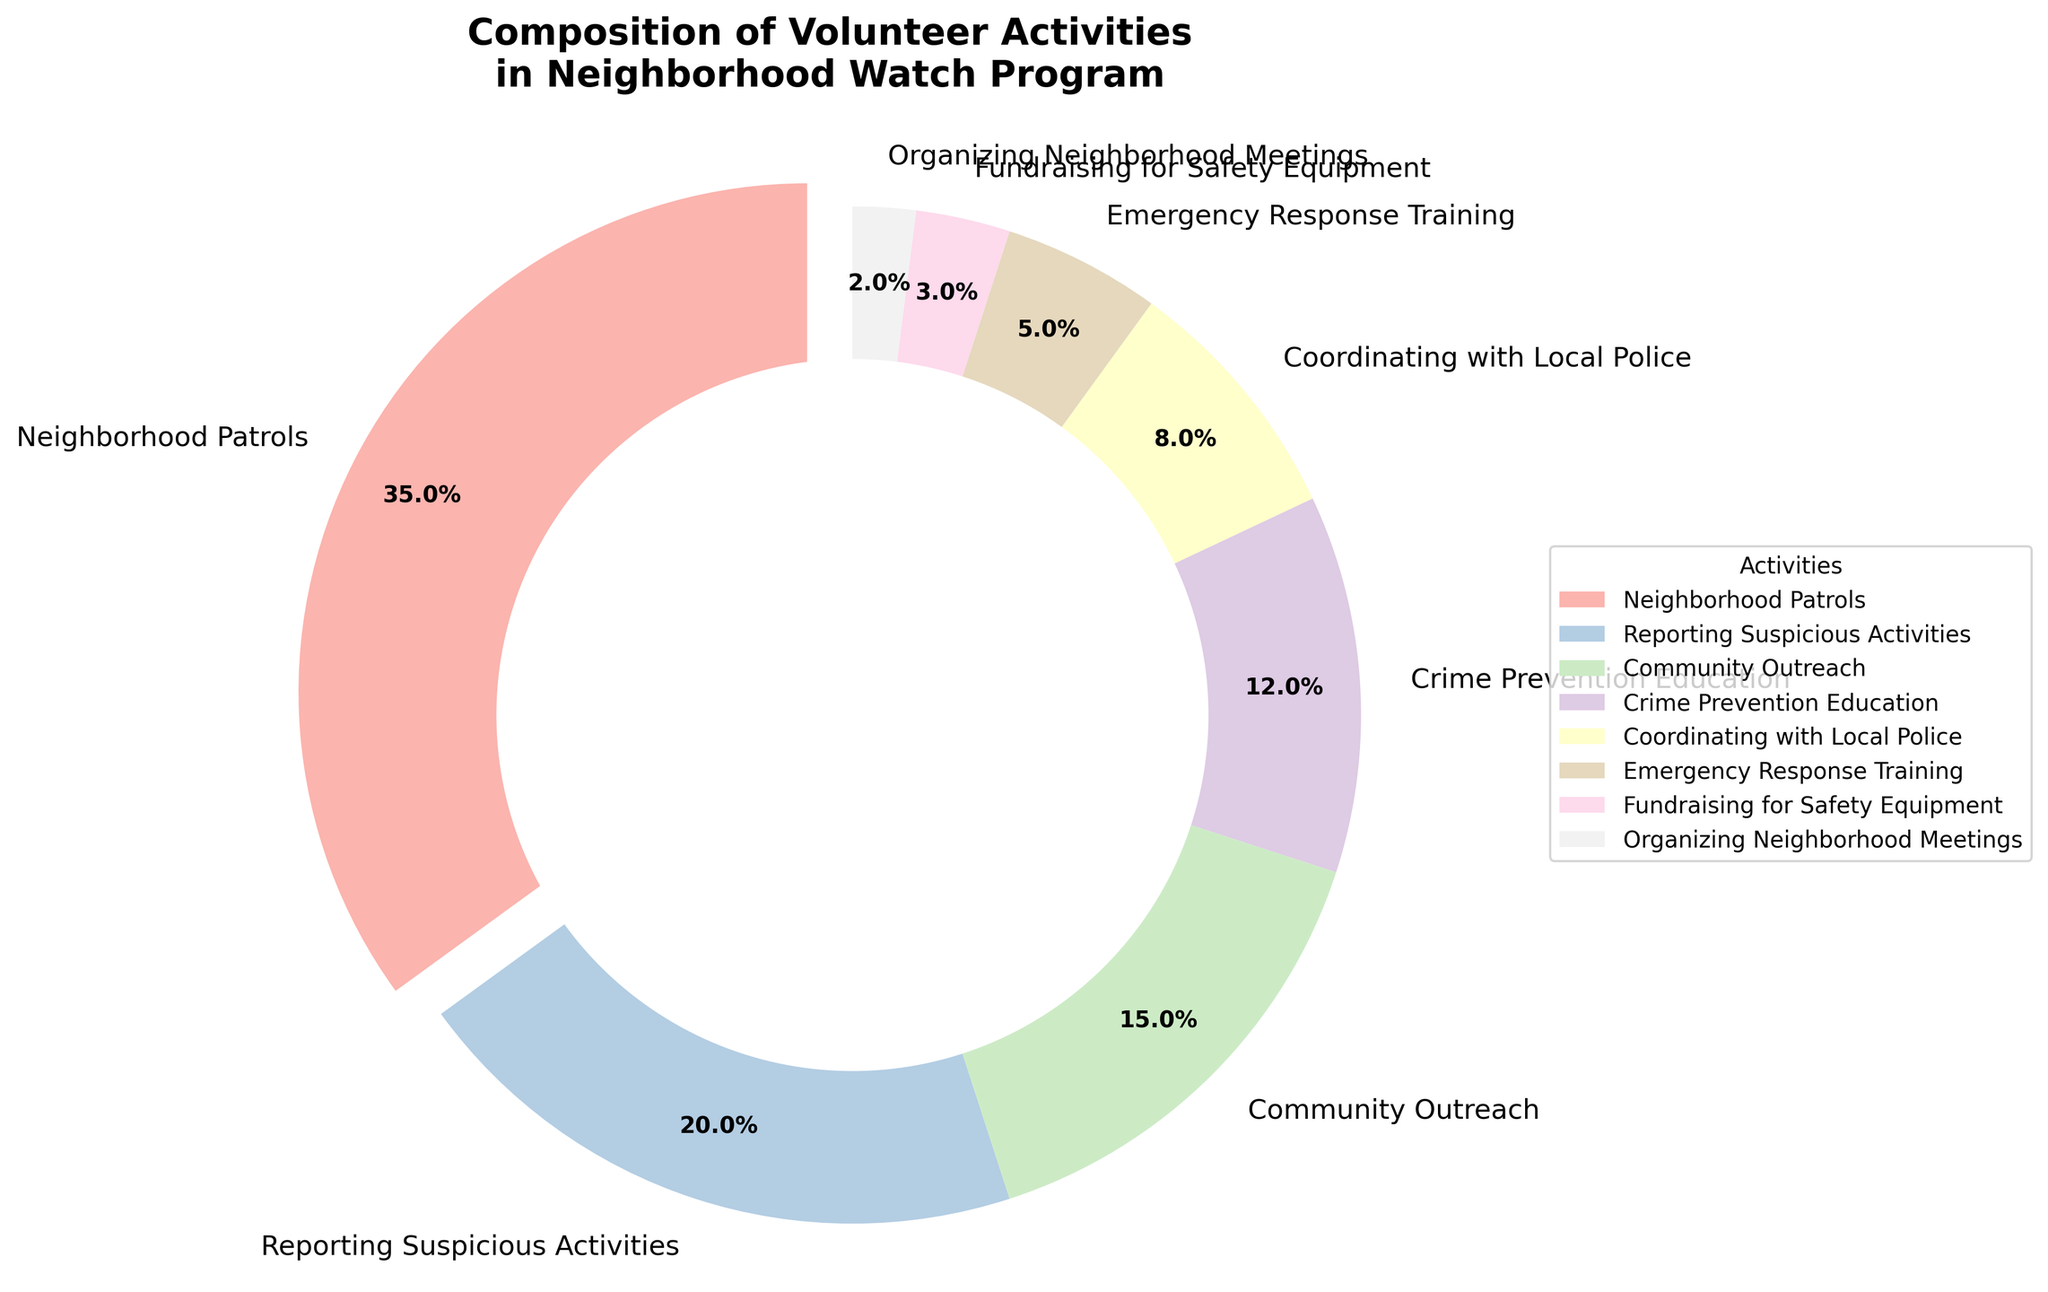What percentage of volunteer activities is dedicated to Neighborhood Patrols? Look at the segment labeled "Neighborhood Patrols" in the pie chart and read the percentage shown.
Answer: 35% How much larger is the percentage of Neighborhood Patrols compared to Crime Prevention Education? Subtract the percentage of Crime Prevention Education from the percentage of Neighborhood Patrols. 35% - 12% = 23%
Answer: 23% Which activity has the second highest percentage of volunteer activities? Identify the segment with the second largest value. The largest is Neighborhood Patrols (35%), and the second largest is Reporting Suspicious Activities at 20%.
Answer: Reporting Suspicious Activities What is the combined percentage of Reporting Suspicious Activities and Community Outreach? Add the percentages of Reporting Suspicious Activities and Community Outreach: 20% + 15% = 35%
Answer: 35% What fraction of the total activities is dedicated to Coordinating with Local Police and Emergency Response Training together? Add the percentages of Coordinating with Local Police and Emergency Response Training: 8% + 5% = 13%. To convert this into a fraction, use 13/100 = 13%.
Answer: 13% Which activities have less than 10% of the total volunteer activities? Identify segments with percentages below 10%: Coordinating with Local Police (8%), Emergency Response Training (5%), Fundraising for Safety Equipment (3%), and Organizing Neighborhood Meetings (2%).
Answer: Coordinating with Local Police, Emergency Response Training, Fundraising for Safety Equipment, Organizing Neighborhood Meetings How many activities have a percentage of participation higher than 10%? Count the segments where the percentage is greater than 10%: Neighborhood Patrols (35%), Reporting Suspicious Activities (20%), Community Outreach (15%), and Crime Prevention Education (12%). There are 4 such activities.
Answer: 4 What is the smallest segment in the pie chart? Identify the segment with the smallest percentage value, which is Organizing Neighborhood Meetings at 2%.
Answer: Organizing Neighborhood Meetings Is the percentage of Fundraising for Safety Equipment higher than the percentage of Emergency Response Training? Compare the percentages for both activities: Fundraising for Safety Equipment (3%) and Emergency Response Training (5%). 3% < 5%, so the answer is no.
Answer: No 